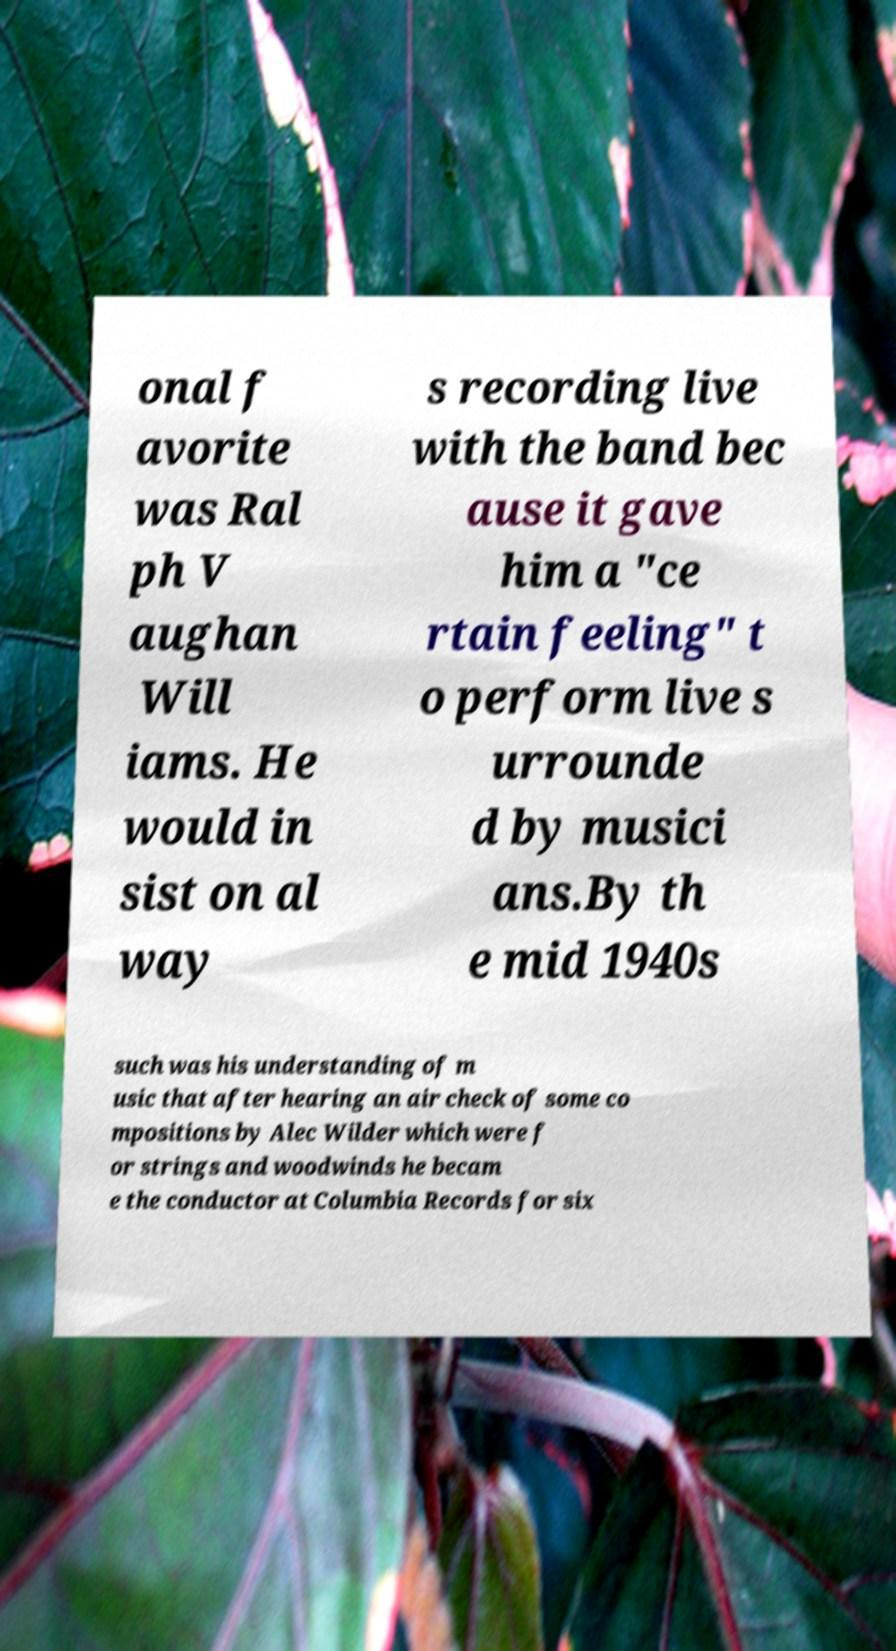For documentation purposes, I need the text within this image transcribed. Could you provide that? onal f avorite was Ral ph V aughan Will iams. He would in sist on al way s recording live with the band bec ause it gave him a "ce rtain feeling" t o perform live s urrounde d by musici ans.By th e mid 1940s such was his understanding of m usic that after hearing an air check of some co mpositions by Alec Wilder which were f or strings and woodwinds he becam e the conductor at Columbia Records for six 